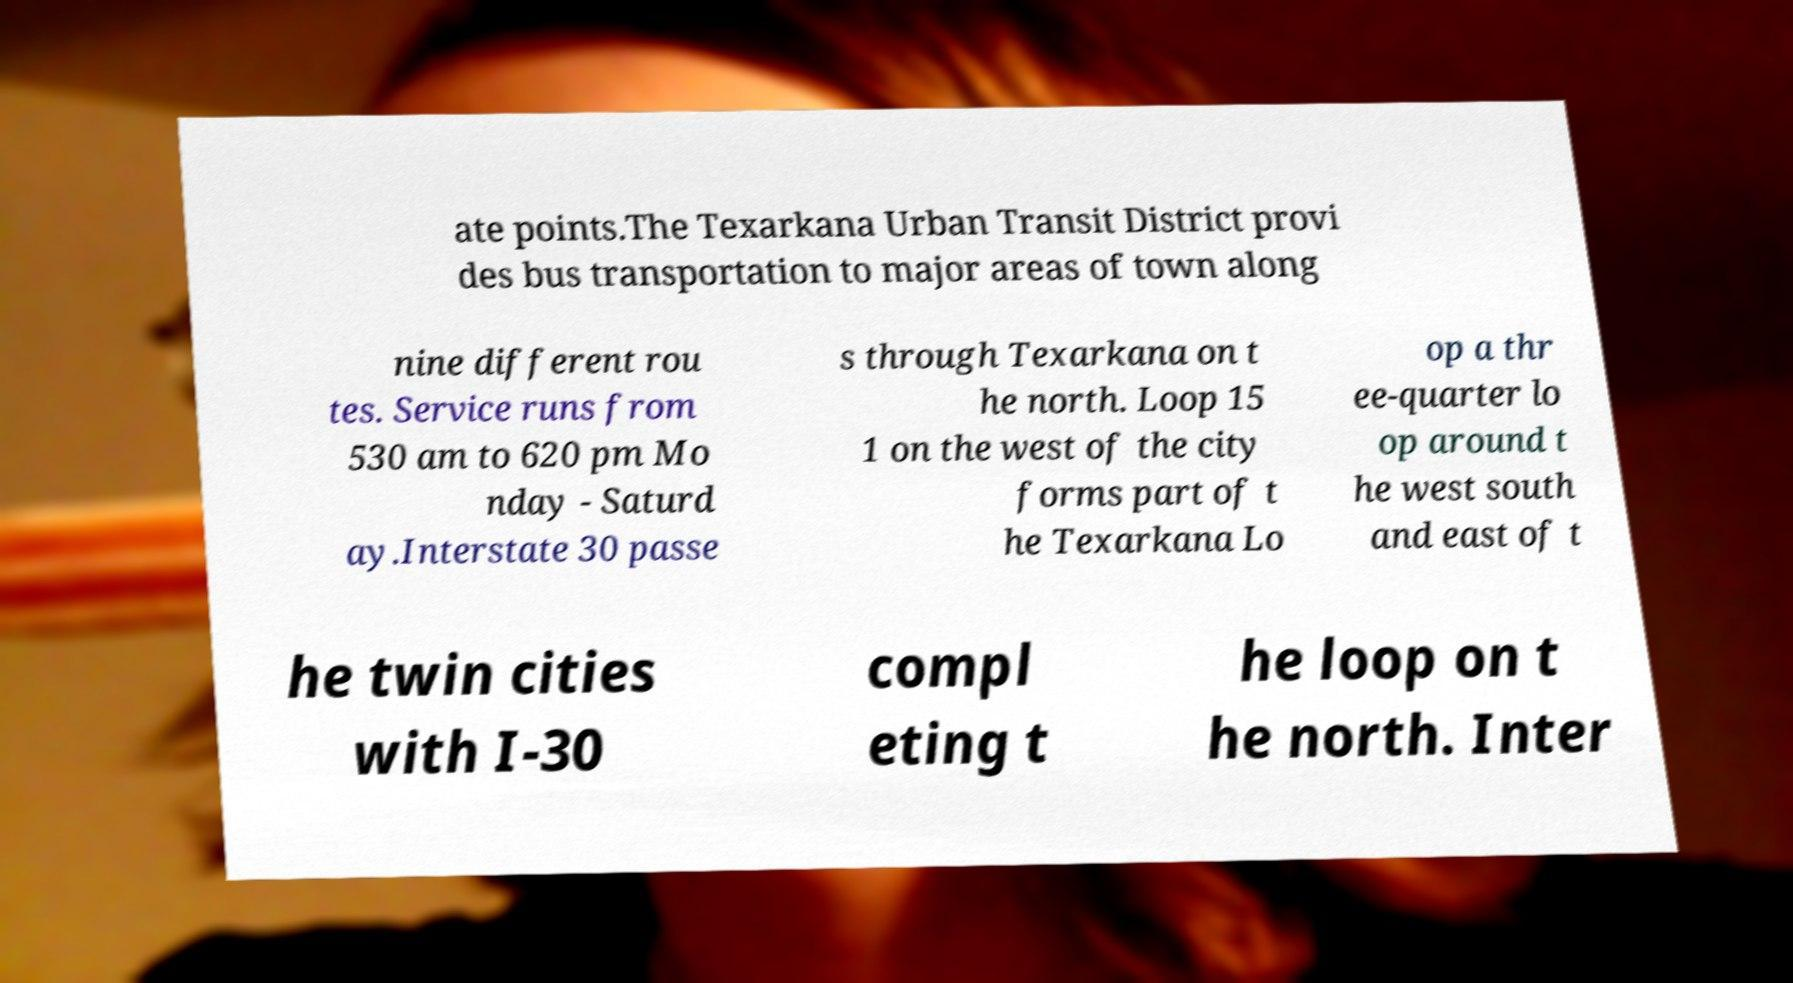Please read and relay the text visible in this image. What does it say? ate points.The Texarkana Urban Transit District provi des bus transportation to major areas of town along nine different rou tes. Service runs from 530 am to 620 pm Mo nday - Saturd ay.Interstate 30 passe s through Texarkana on t he north. Loop 15 1 on the west of the city forms part of t he Texarkana Lo op a thr ee-quarter lo op around t he west south and east of t he twin cities with I-30 compl eting t he loop on t he north. Inter 